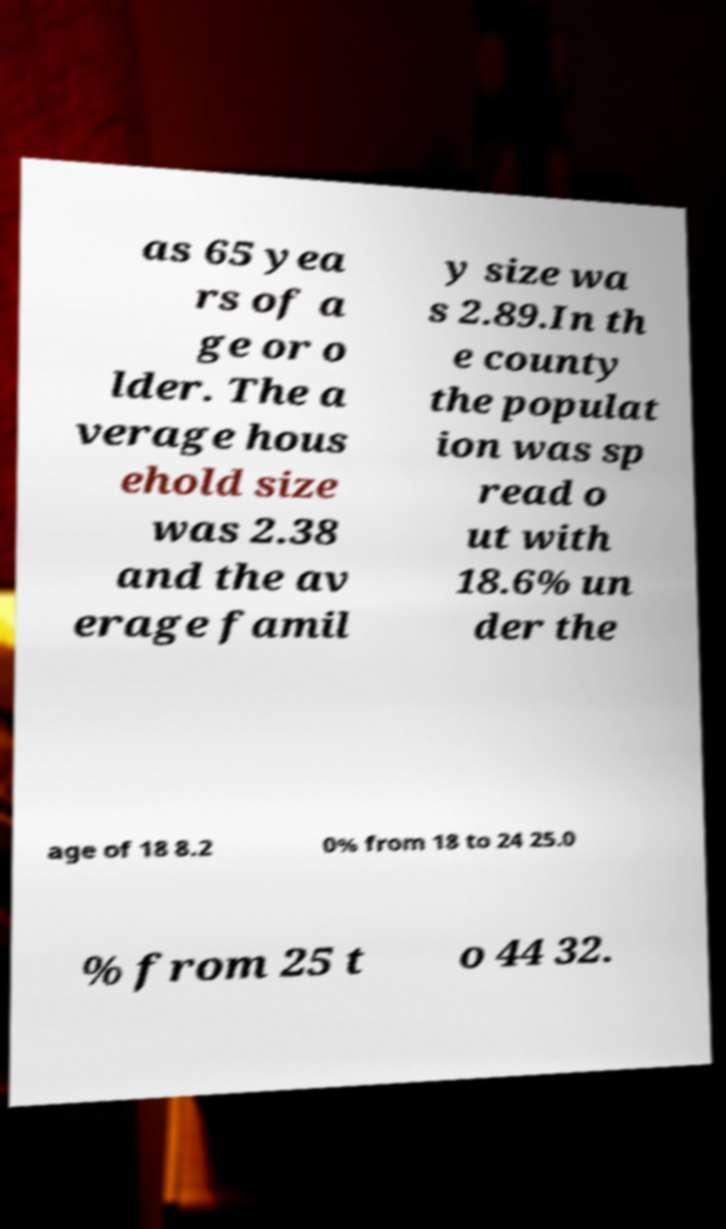For documentation purposes, I need the text within this image transcribed. Could you provide that? as 65 yea rs of a ge or o lder. The a verage hous ehold size was 2.38 and the av erage famil y size wa s 2.89.In th e county the populat ion was sp read o ut with 18.6% un der the age of 18 8.2 0% from 18 to 24 25.0 % from 25 t o 44 32. 